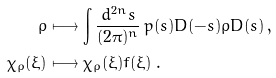Convert formula to latex. <formula><loc_0><loc_0><loc_500><loc_500>\rho & \longmapsto \int \frac { d ^ { 2 n } s } { ( 2 \pi ) ^ { n } } \, p ( s ) D ( - s ) \rho D ( s ) \, , \\ \chi _ { \rho } ( \xi ) & \longmapsto \chi _ { \rho } ( \xi ) f ( \xi ) \, .</formula> 